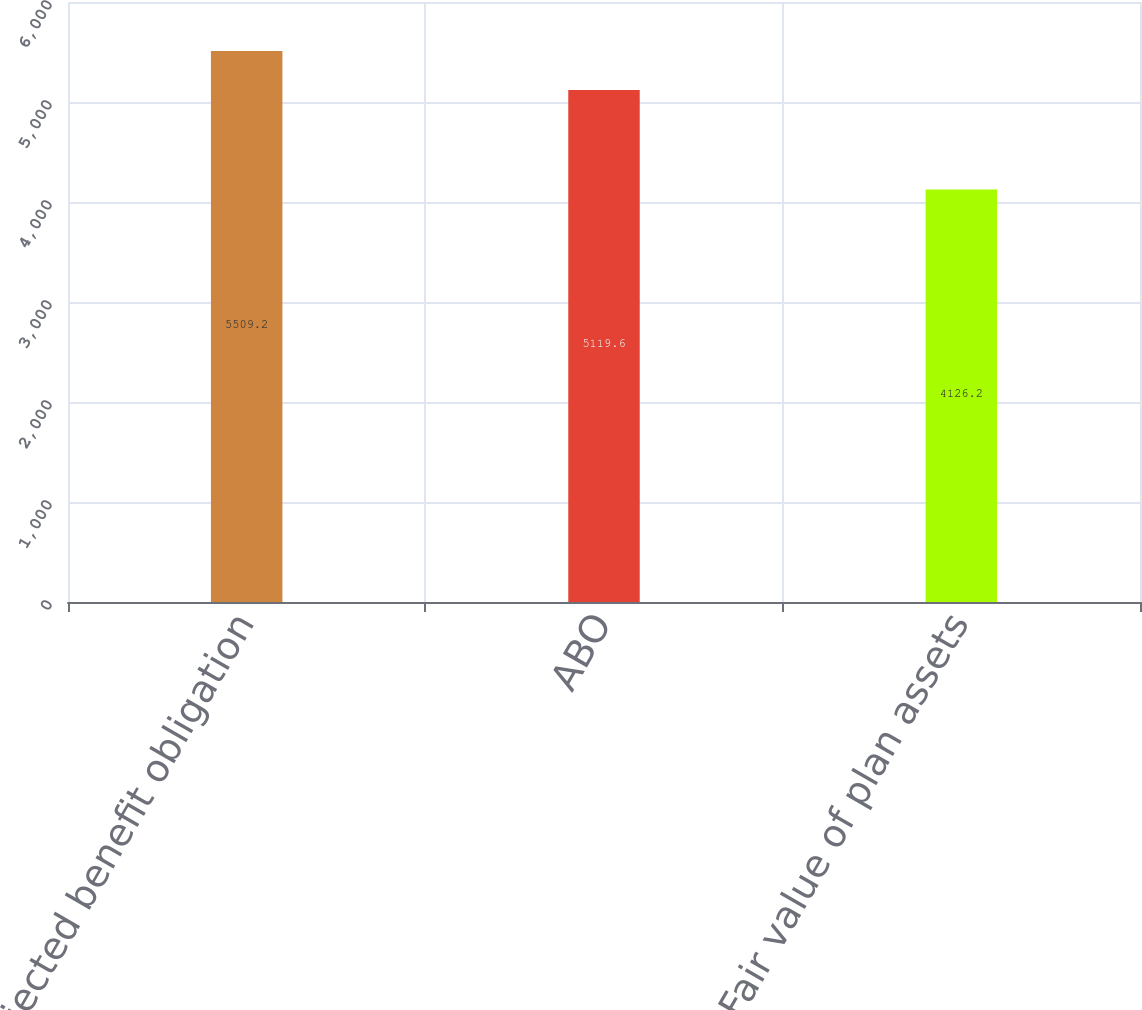<chart> <loc_0><loc_0><loc_500><loc_500><bar_chart><fcel>Projected benefit obligation<fcel>ABO<fcel>Fair value of plan assets<nl><fcel>5509.2<fcel>5119.6<fcel>4126.2<nl></chart> 